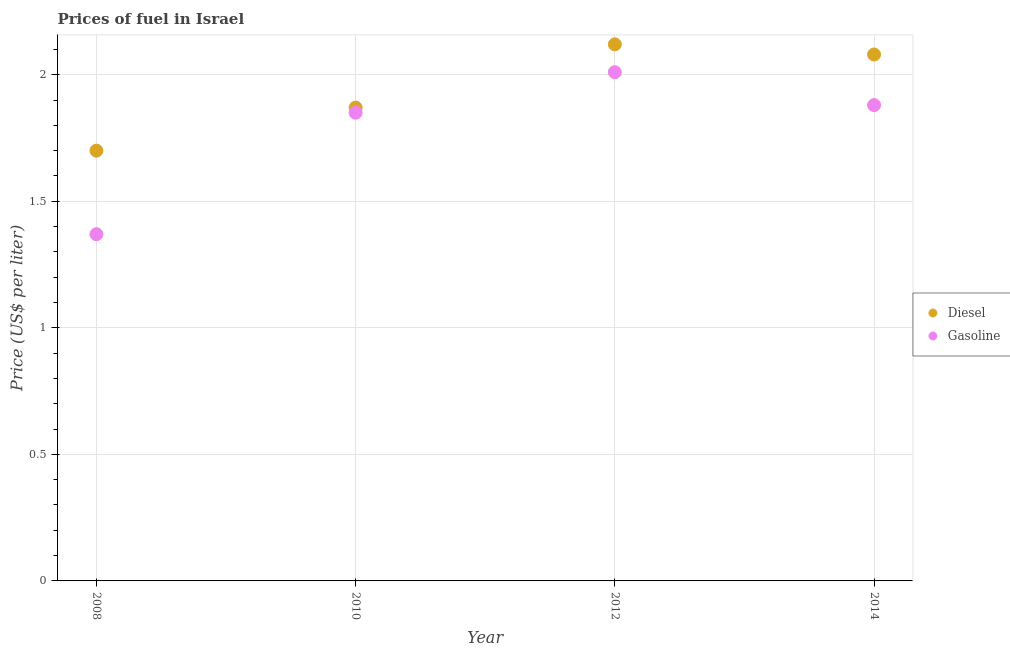How many different coloured dotlines are there?
Provide a short and direct response. 2. Is the number of dotlines equal to the number of legend labels?
Keep it short and to the point. Yes. What is the gasoline price in 2010?
Keep it short and to the point. 1.85. Across all years, what is the maximum gasoline price?
Provide a short and direct response. 2.01. Across all years, what is the minimum gasoline price?
Your response must be concise. 1.37. In which year was the diesel price maximum?
Offer a terse response. 2012. In which year was the gasoline price minimum?
Your answer should be compact. 2008. What is the total gasoline price in the graph?
Make the answer very short. 7.11. What is the difference between the diesel price in 2008 and that in 2012?
Offer a terse response. -0.42. What is the difference between the gasoline price in 2012 and the diesel price in 2008?
Give a very brief answer. 0.31. What is the average diesel price per year?
Give a very brief answer. 1.94. In the year 2012, what is the difference between the gasoline price and diesel price?
Your response must be concise. -0.11. What is the ratio of the diesel price in 2008 to that in 2012?
Your response must be concise. 0.8. Is the diesel price in 2008 less than that in 2010?
Ensure brevity in your answer.  Yes. What is the difference between the highest and the second highest gasoline price?
Your response must be concise. 0.13. What is the difference between the highest and the lowest gasoline price?
Provide a succinct answer. 0.64. Is the sum of the gasoline price in 2010 and 2012 greater than the maximum diesel price across all years?
Offer a very short reply. Yes. Is the gasoline price strictly greater than the diesel price over the years?
Ensure brevity in your answer.  No. Is the diesel price strictly less than the gasoline price over the years?
Your answer should be very brief. No. Are the values on the major ticks of Y-axis written in scientific E-notation?
Provide a short and direct response. No. How many legend labels are there?
Ensure brevity in your answer.  2. What is the title of the graph?
Offer a terse response. Prices of fuel in Israel. Does "Frequency of shipment arrival" appear as one of the legend labels in the graph?
Give a very brief answer. No. What is the label or title of the X-axis?
Your answer should be very brief. Year. What is the label or title of the Y-axis?
Offer a very short reply. Price (US$ per liter). What is the Price (US$ per liter) in Gasoline in 2008?
Your answer should be compact. 1.37. What is the Price (US$ per liter) in Diesel in 2010?
Make the answer very short. 1.87. What is the Price (US$ per liter) in Gasoline in 2010?
Your answer should be compact. 1.85. What is the Price (US$ per liter) in Diesel in 2012?
Your answer should be compact. 2.12. What is the Price (US$ per liter) in Gasoline in 2012?
Offer a very short reply. 2.01. What is the Price (US$ per liter) of Diesel in 2014?
Give a very brief answer. 2.08. What is the Price (US$ per liter) in Gasoline in 2014?
Offer a terse response. 1.88. Across all years, what is the maximum Price (US$ per liter) in Diesel?
Ensure brevity in your answer.  2.12. Across all years, what is the maximum Price (US$ per liter) of Gasoline?
Make the answer very short. 2.01. Across all years, what is the minimum Price (US$ per liter) of Diesel?
Make the answer very short. 1.7. Across all years, what is the minimum Price (US$ per liter) in Gasoline?
Provide a succinct answer. 1.37. What is the total Price (US$ per liter) in Diesel in the graph?
Your response must be concise. 7.77. What is the total Price (US$ per liter) of Gasoline in the graph?
Make the answer very short. 7.11. What is the difference between the Price (US$ per liter) in Diesel in 2008 and that in 2010?
Your response must be concise. -0.17. What is the difference between the Price (US$ per liter) of Gasoline in 2008 and that in 2010?
Your answer should be very brief. -0.48. What is the difference between the Price (US$ per liter) in Diesel in 2008 and that in 2012?
Your answer should be compact. -0.42. What is the difference between the Price (US$ per liter) of Gasoline in 2008 and that in 2012?
Provide a short and direct response. -0.64. What is the difference between the Price (US$ per liter) of Diesel in 2008 and that in 2014?
Ensure brevity in your answer.  -0.38. What is the difference between the Price (US$ per liter) of Gasoline in 2008 and that in 2014?
Ensure brevity in your answer.  -0.51. What is the difference between the Price (US$ per liter) of Gasoline in 2010 and that in 2012?
Your answer should be very brief. -0.16. What is the difference between the Price (US$ per liter) of Diesel in 2010 and that in 2014?
Your response must be concise. -0.21. What is the difference between the Price (US$ per liter) of Gasoline in 2010 and that in 2014?
Your answer should be very brief. -0.03. What is the difference between the Price (US$ per liter) of Gasoline in 2012 and that in 2014?
Your answer should be compact. 0.13. What is the difference between the Price (US$ per liter) of Diesel in 2008 and the Price (US$ per liter) of Gasoline in 2012?
Ensure brevity in your answer.  -0.31. What is the difference between the Price (US$ per liter) of Diesel in 2008 and the Price (US$ per liter) of Gasoline in 2014?
Make the answer very short. -0.18. What is the difference between the Price (US$ per liter) of Diesel in 2010 and the Price (US$ per liter) of Gasoline in 2012?
Your answer should be very brief. -0.14. What is the difference between the Price (US$ per liter) in Diesel in 2010 and the Price (US$ per liter) in Gasoline in 2014?
Your answer should be very brief. -0.01. What is the difference between the Price (US$ per liter) in Diesel in 2012 and the Price (US$ per liter) in Gasoline in 2014?
Offer a terse response. 0.24. What is the average Price (US$ per liter) in Diesel per year?
Provide a short and direct response. 1.94. What is the average Price (US$ per liter) in Gasoline per year?
Your response must be concise. 1.78. In the year 2008, what is the difference between the Price (US$ per liter) of Diesel and Price (US$ per liter) of Gasoline?
Ensure brevity in your answer.  0.33. In the year 2010, what is the difference between the Price (US$ per liter) of Diesel and Price (US$ per liter) of Gasoline?
Your answer should be very brief. 0.02. In the year 2012, what is the difference between the Price (US$ per liter) of Diesel and Price (US$ per liter) of Gasoline?
Ensure brevity in your answer.  0.11. In the year 2014, what is the difference between the Price (US$ per liter) of Diesel and Price (US$ per liter) of Gasoline?
Offer a very short reply. 0.2. What is the ratio of the Price (US$ per liter) in Diesel in 2008 to that in 2010?
Your answer should be very brief. 0.91. What is the ratio of the Price (US$ per liter) of Gasoline in 2008 to that in 2010?
Your response must be concise. 0.74. What is the ratio of the Price (US$ per liter) in Diesel in 2008 to that in 2012?
Provide a short and direct response. 0.8. What is the ratio of the Price (US$ per liter) in Gasoline in 2008 to that in 2012?
Your answer should be very brief. 0.68. What is the ratio of the Price (US$ per liter) in Diesel in 2008 to that in 2014?
Provide a succinct answer. 0.82. What is the ratio of the Price (US$ per liter) in Gasoline in 2008 to that in 2014?
Keep it short and to the point. 0.73. What is the ratio of the Price (US$ per liter) of Diesel in 2010 to that in 2012?
Ensure brevity in your answer.  0.88. What is the ratio of the Price (US$ per liter) in Gasoline in 2010 to that in 2012?
Ensure brevity in your answer.  0.92. What is the ratio of the Price (US$ per liter) in Diesel in 2010 to that in 2014?
Your answer should be compact. 0.9. What is the ratio of the Price (US$ per liter) in Diesel in 2012 to that in 2014?
Keep it short and to the point. 1.02. What is the ratio of the Price (US$ per liter) in Gasoline in 2012 to that in 2014?
Your answer should be very brief. 1.07. What is the difference between the highest and the second highest Price (US$ per liter) of Diesel?
Keep it short and to the point. 0.04. What is the difference between the highest and the second highest Price (US$ per liter) in Gasoline?
Keep it short and to the point. 0.13. What is the difference between the highest and the lowest Price (US$ per liter) of Diesel?
Your response must be concise. 0.42. What is the difference between the highest and the lowest Price (US$ per liter) in Gasoline?
Provide a succinct answer. 0.64. 